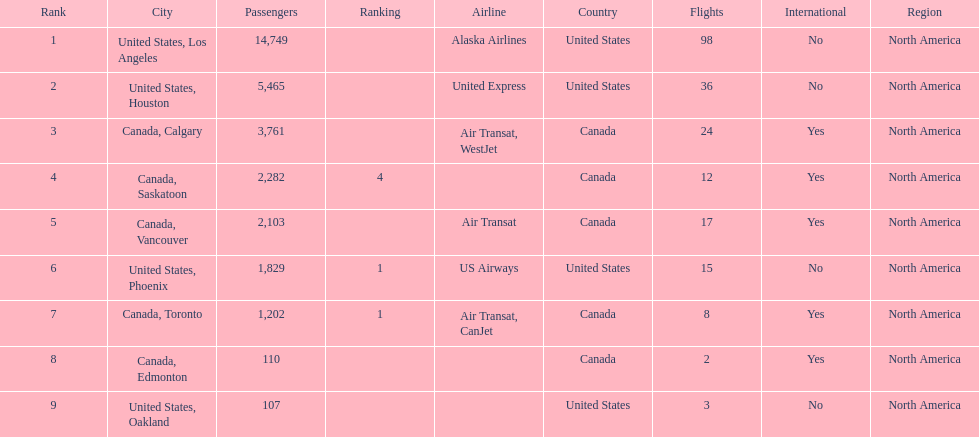Would you be able to parse every entry in this table? {'header': ['Rank', 'City', 'Passengers', 'Ranking', 'Airline', 'Country', 'Flights', 'International', 'Region'], 'rows': [['1', 'United States, Los Angeles', '14,749', '', 'Alaska Airlines', 'United States', '98', 'No', 'North America'], ['2', 'United States, Houston', '5,465', '', 'United Express', 'United States', '36', 'No', 'North America'], ['3', 'Canada, Calgary', '3,761', '', 'Air Transat, WestJet', 'Canada', '24', 'Yes', 'North America'], ['4', 'Canada, Saskatoon', '2,282', '4', '', 'Canada', '12', 'Yes', 'North America'], ['5', 'Canada, Vancouver', '2,103', '', 'Air Transat', 'Canada', '17', 'Yes', 'North America'], ['6', 'United States, Phoenix', '1,829', '1', 'US Airways', 'United States', '15', 'No', 'North America'], ['7', 'Canada, Toronto', '1,202', '1', 'Air Transat, CanJet', 'Canada', '8', 'Yes', 'North America'], ['8', 'Canada, Edmonton', '110', '', '', 'Canada', '2', 'Yes', 'North America'], ['9', 'United States, Oakland', '107', '', '', 'United States', '3', 'No', 'North America']]} How many airlines have a steady ranking? 4. 